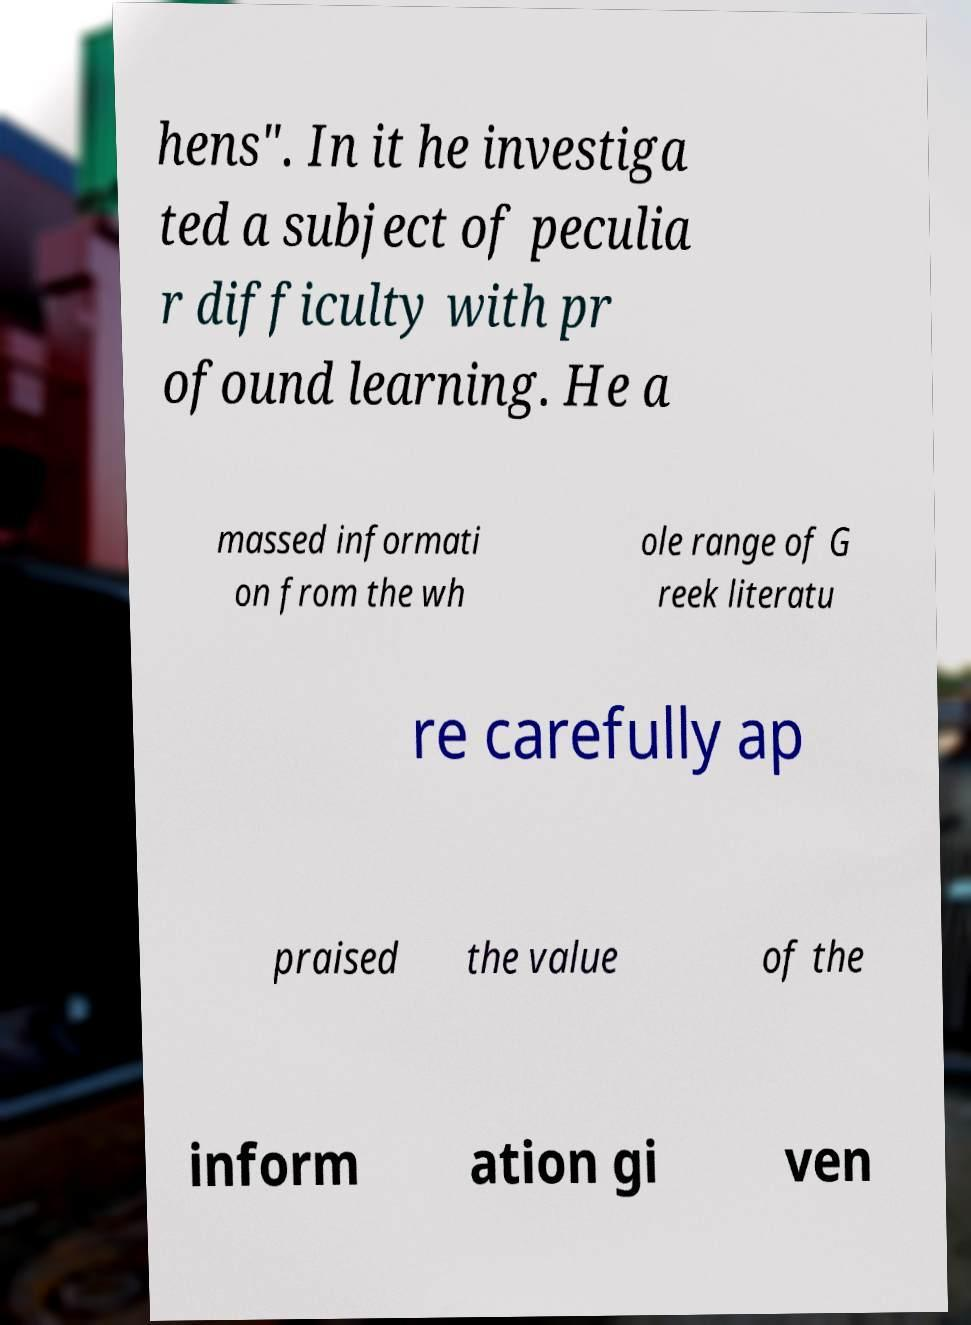Please read and relay the text visible in this image. What does it say? hens". In it he investiga ted a subject of peculia r difficulty with pr ofound learning. He a massed informati on from the wh ole range of G reek literatu re carefully ap praised the value of the inform ation gi ven 